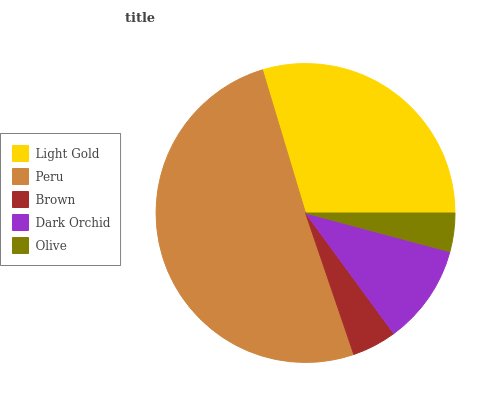Is Olive the minimum?
Answer yes or no. Yes. Is Peru the maximum?
Answer yes or no. Yes. Is Brown the minimum?
Answer yes or no. No. Is Brown the maximum?
Answer yes or no. No. Is Peru greater than Brown?
Answer yes or no. Yes. Is Brown less than Peru?
Answer yes or no. Yes. Is Brown greater than Peru?
Answer yes or no. No. Is Peru less than Brown?
Answer yes or no. No. Is Dark Orchid the high median?
Answer yes or no. Yes. Is Dark Orchid the low median?
Answer yes or no. Yes. Is Olive the high median?
Answer yes or no. No. Is Peru the low median?
Answer yes or no. No. 